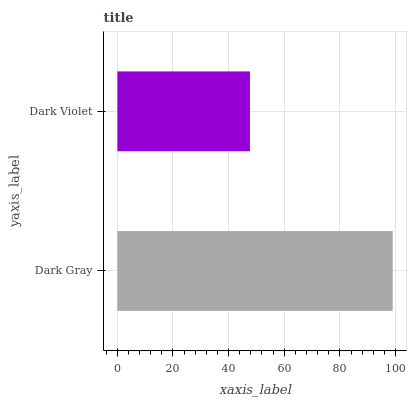Is Dark Violet the minimum?
Answer yes or no. Yes. Is Dark Gray the maximum?
Answer yes or no. Yes. Is Dark Violet the maximum?
Answer yes or no. No. Is Dark Gray greater than Dark Violet?
Answer yes or no. Yes. Is Dark Violet less than Dark Gray?
Answer yes or no. Yes. Is Dark Violet greater than Dark Gray?
Answer yes or no. No. Is Dark Gray less than Dark Violet?
Answer yes or no. No. Is Dark Gray the high median?
Answer yes or no. Yes. Is Dark Violet the low median?
Answer yes or no. Yes. Is Dark Violet the high median?
Answer yes or no. No. Is Dark Gray the low median?
Answer yes or no. No. 